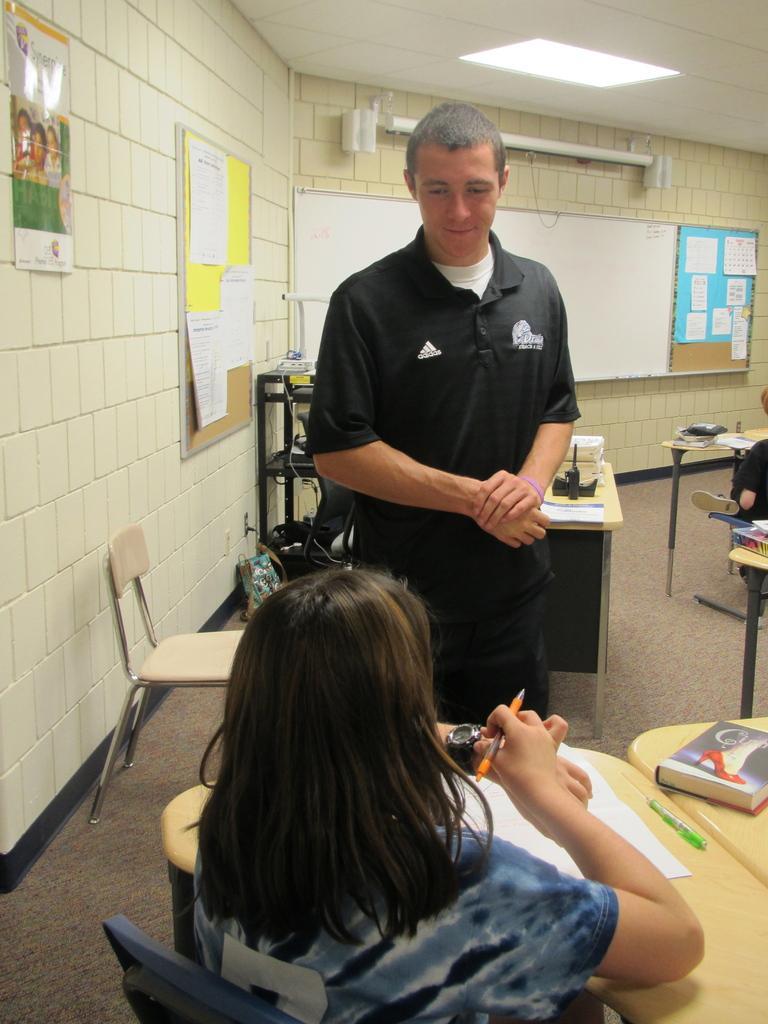Describe this image in one or two sentences. In this picture a woman is seated on the chair, and a man is standing in front of her, she is looking into her watch, in front of a her we can find a book and papers on the table, in the background we can see couple of of posters and notice boards on the wall, and also we can find a projector screen and a light. 